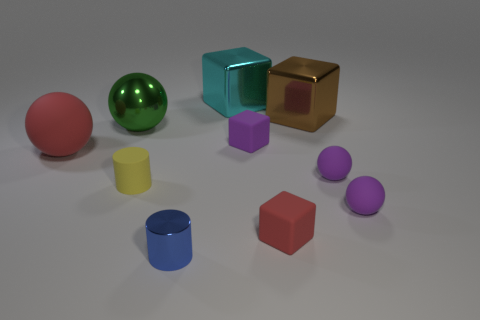Is the size of the blue metal cylinder the same as the matte cube that is on the right side of the purple rubber cube?
Offer a very short reply. Yes. What color is the metal thing that is to the left of the cyan block and behind the blue cylinder?
Make the answer very short. Green. What number of other objects are there of the same shape as the big brown object?
Offer a very short reply. 3. There is a matte ball that is to the left of the green thing; is its color the same as the big thing that is to the right of the small purple rubber block?
Offer a very short reply. No. Do the sphere to the left of the green ball and the purple object that is left of the large brown metallic object have the same size?
Your answer should be very brief. No. Is there any other thing that has the same material as the brown thing?
Keep it short and to the point. Yes. What material is the red object that is right of the metallic cylinder on the left side of the block behind the large brown shiny object made of?
Offer a terse response. Rubber. Does the yellow thing have the same shape as the brown object?
Give a very brief answer. No. What material is the big green thing that is the same shape as the large red matte thing?
Make the answer very short. Metal. How many large rubber spheres are the same color as the tiny metal cylinder?
Make the answer very short. 0. 